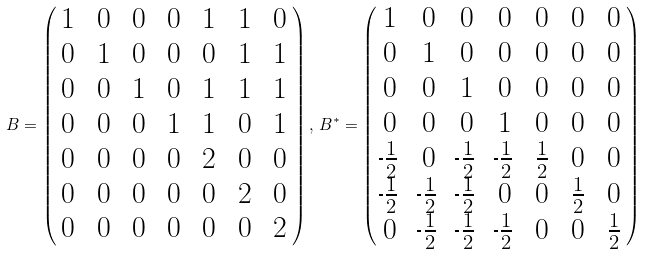<formula> <loc_0><loc_0><loc_500><loc_500>\ B = \begin{pmatrix} \, 1 & \, 0 & \, 0 & \, 0 & \, 1 & \, 1 & \, 0 \, \\ \, 0 & \, 1 & \, 0 & \, 0 & \, 0 & \, 1 & \, 1 \, \\ \, 0 & \, 0 & \, 1 & \, 0 & \, 1 & \, 1 & \, 1 \, \\ \, 0 & \, 0 & \, 0 & \, 1 & \, 1 & \, 0 & \, 1 \, \\ \, 0 & \, 0 & \, 0 & \, 0 & \, 2 & \, 0 & \, 0 \, \\ \, 0 & \, 0 & \, 0 & \, 0 & \, 0 & \, 2 & \, 0 \, \\ \, 0 & \, 0 & \, 0 & \, 0 & \, 0 & \, 0 & \, 2 \, \\ \end{pmatrix} , \, B ^ { * } = \begin{pmatrix} \, 1 & \, 0 & \, 0 & \, 0 & \, 0 & \, 0 & \, 0 \, \\ \, 0 & \, 1 & \, 0 & \, 0 & \, 0 & \, 0 & \, 0 \, \\ \, 0 & \, 0 & \, 1 & \, 0 & \, 0 & \, 0 & \, 0 \, \\ \, 0 & \, 0 & \, 0 & \, 1 & \, 0 & \, 0 & \, 0 \, \\ \frac { \, } { \, } \frac { 1 } { 2 } & \, 0 & \frac { \, } { \, } \frac { 1 } { 2 } & \frac { \, } { \, } \frac { 1 } { 2 } & \, \frac { 1 } { 2 } & \, 0 & \, 0 \, \\ \frac { \, } { \, } \frac { 1 } { 2 } & \frac { \, } { \, } \frac { 1 } { 2 } & \frac { \, } { \, } \frac { 1 } { 2 } & \, 0 & \, 0 & \, \frac { 1 } { 2 } & \, 0 \, \\ \, 0 & \frac { \, } { \, } \frac { 1 } { 2 } & \frac { \, } { \, } \frac { 1 } { 2 } & \frac { \, } { \, } \frac { 1 } { 2 } & \, 0 & \, 0 & \, \frac { 1 } { 2 } \, \\ \end{pmatrix}</formula> 